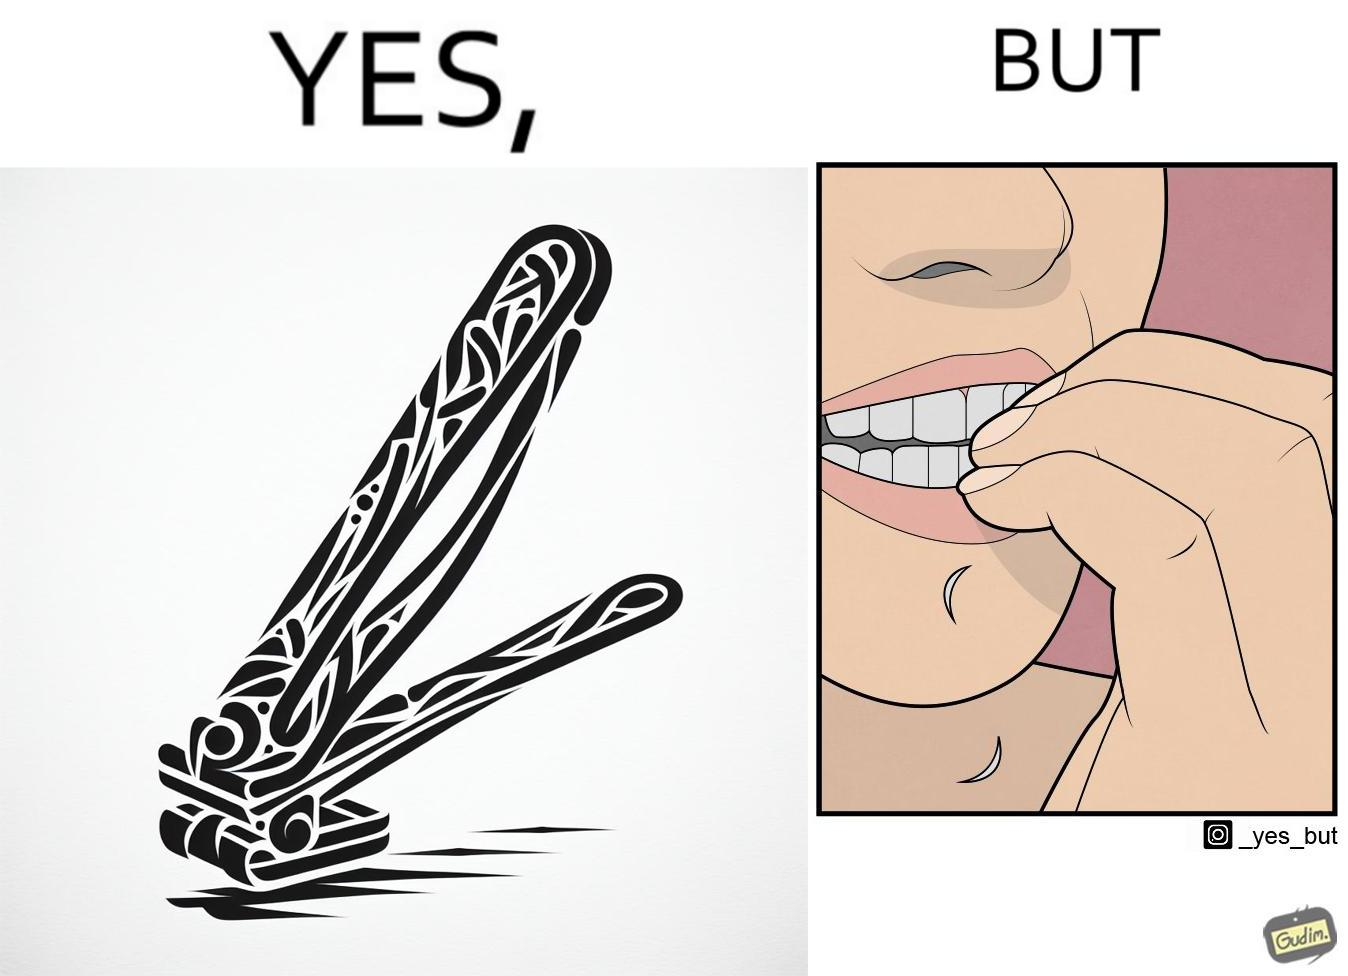Describe the contrast between the left and right parts of this image. In the left part of the image: a nail clipper In the right part of the image: a person biting their nails to cut them 